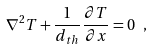Convert formula to latex. <formula><loc_0><loc_0><loc_500><loc_500>\nabla ^ { 2 } T + \frac { 1 } { d _ { t h } } \frac { \partial T } { \partial x } = 0 \ ,</formula> 